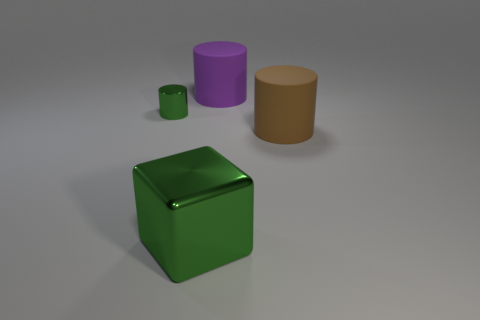Subtract all small green cylinders. How many cylinders are left? 2 Add 2 large green cubes. How many objects exist? 6 Subtract all green cylinders. How many cylinders are left? 2 Subtract 0 cyan cubes. How many objects are left? 4 Subtract all cylinders. How many objects are left? 1 Subtract 2 cylinders. How many cylinders are left? 1 Subtract all cyan cylinders. Subtract all gray balls. How many cylinders are left? 3 Subtract all blue spheres. How many purple cylinders are left? 1 Subtract all metal objects. Subtract all large cylinders. How many objects are left? 0 Add 3 large rubber cylinders. How many large rubber cylinders are left? 5 